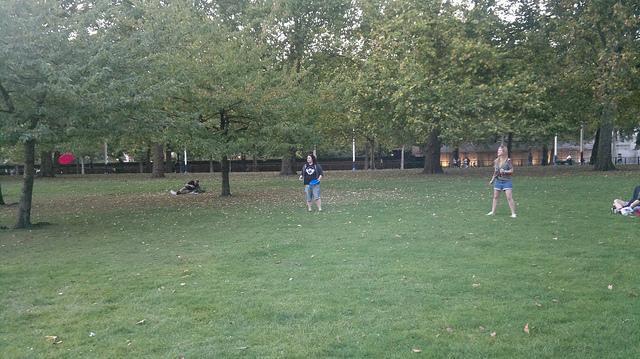How many people are standing?
Give a very brief answer. 2. 